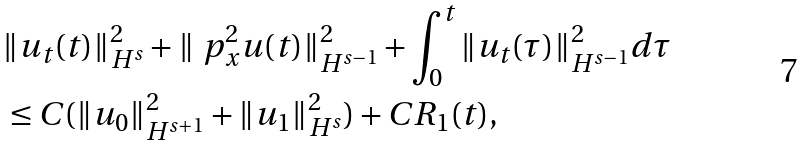<formula> <loc_0><loc_0><loc_500><loc_500>& \| u _ { t } ( t ) \| ^ { 2 } _ { H ^ { s } } + \| \ p ^ { 2 } _ { x } u ( t ) \| ^ { 2 } _ { H ^ { s - 1 } } + \int ^ { t } _ { 0 } \| u _ { t } ( \tau ) \| ^ { 2 } _ { H ^ { s - 1 } } d \tau \\ & \leq C ( \| u _ { 0 } \| ^ { 2 } _ { H ^ { s + 1 } } + \| u _ { 1 } \| ^ { 2 } _ { H ^ { s } } ) + C R _ { 1 } ( t ) ,</formula> 